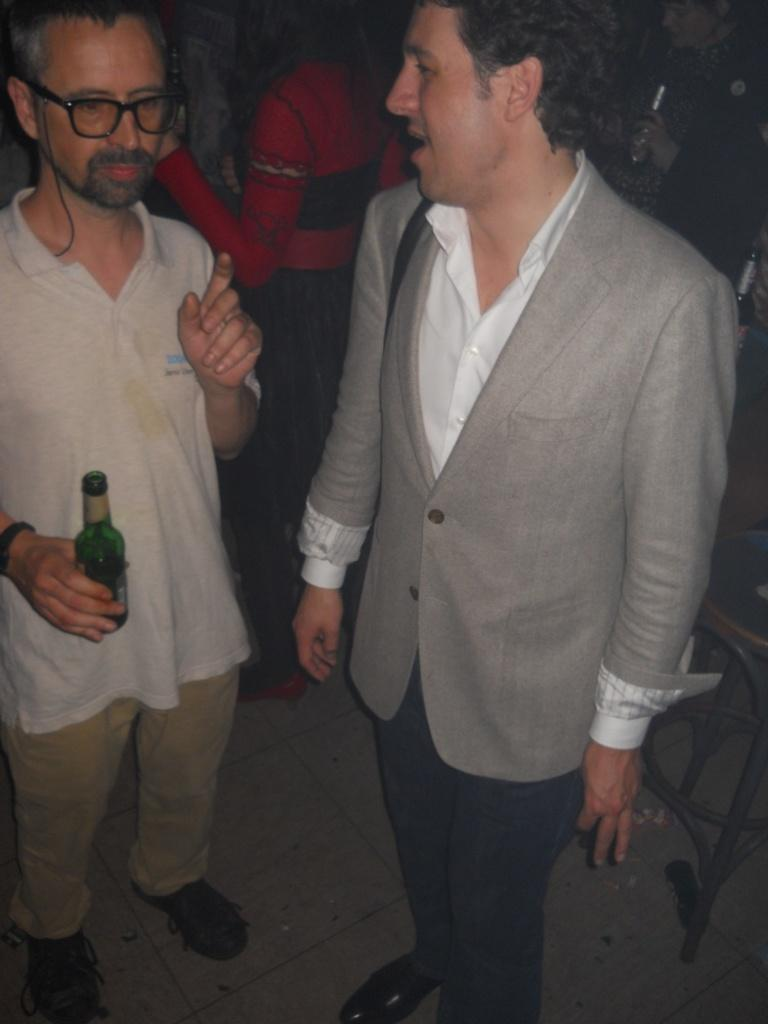How many people are in the image? There are two men in the image. Can you describe one of the men in the image? One of the men is wearing spectacles. What is the man with spectacles holding in his hand? The man with spectacles is holding a bottle in his hand. What type of treatment is the man with spectacles receiving in the image? There is no indication in the image that the man with spectacles is receiving any treatment. 